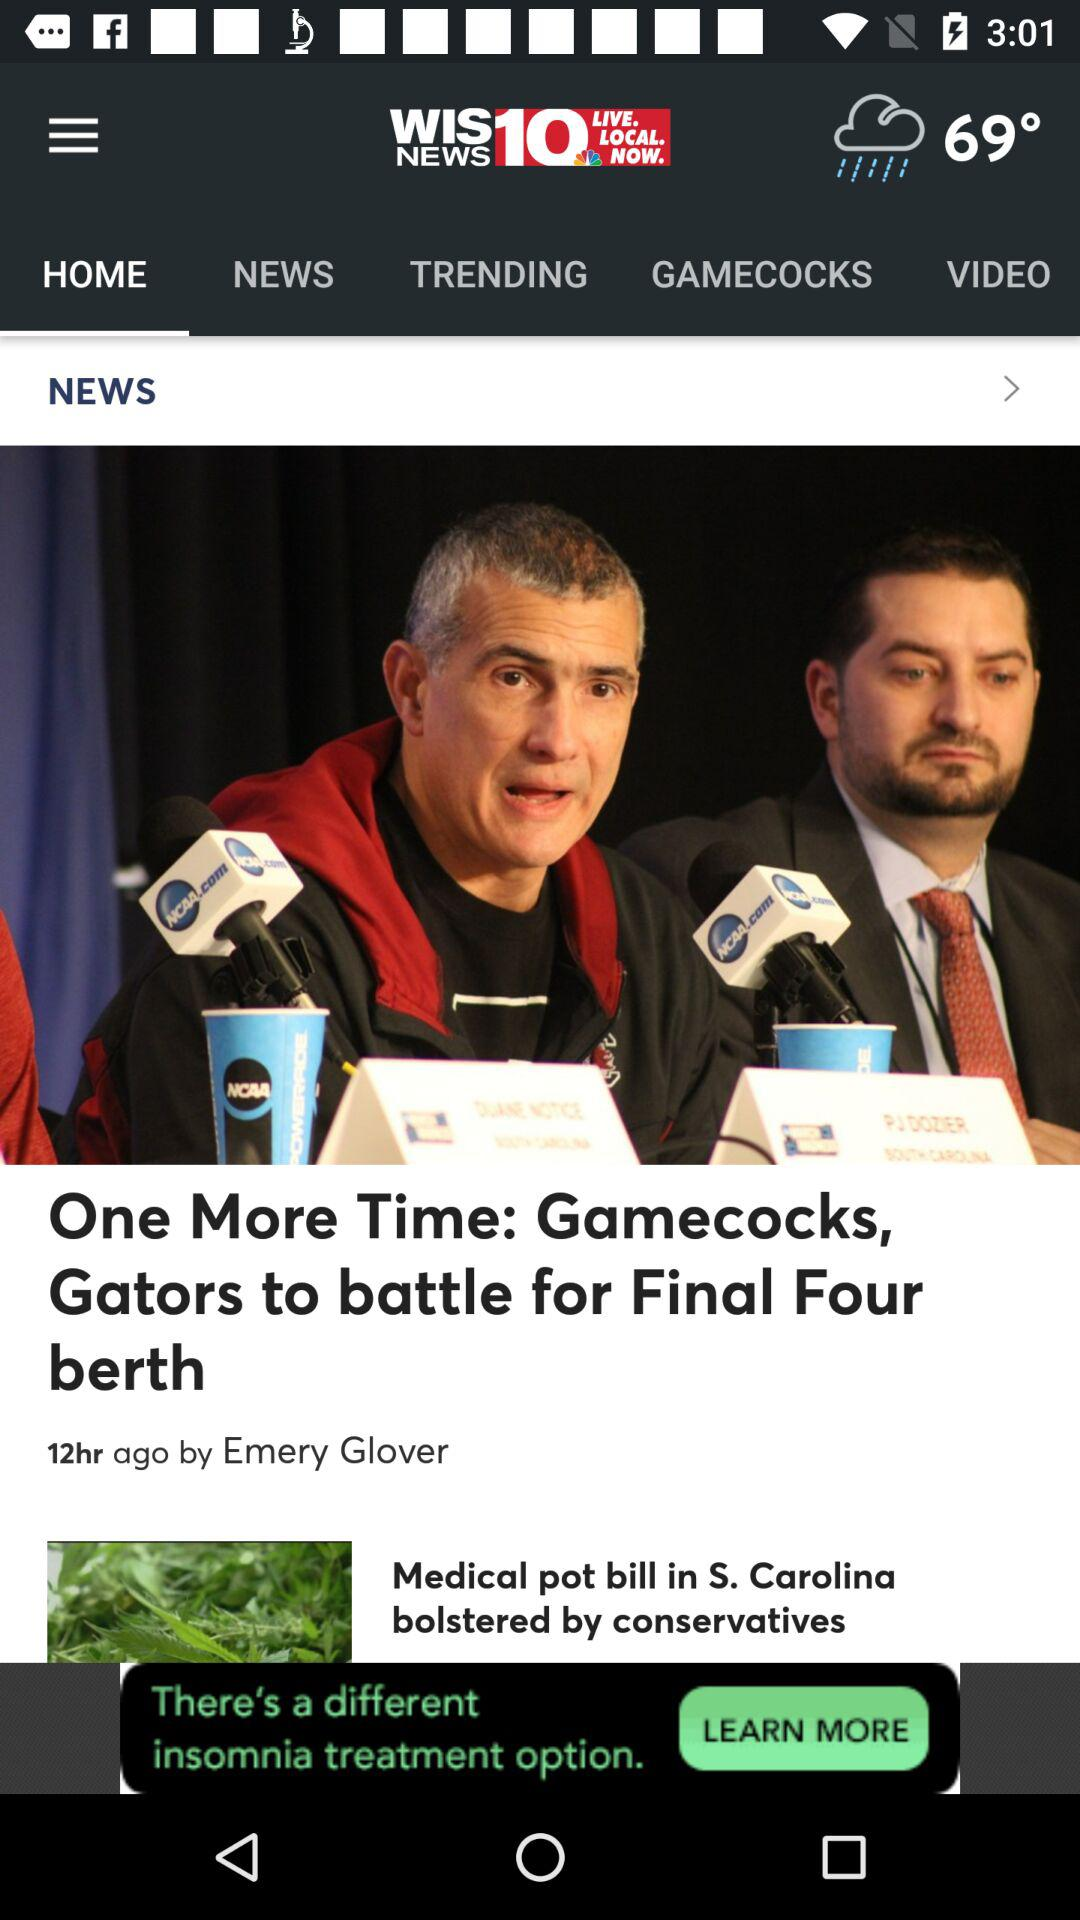By whom is the article posted? The article is posted by Emery Glover. 